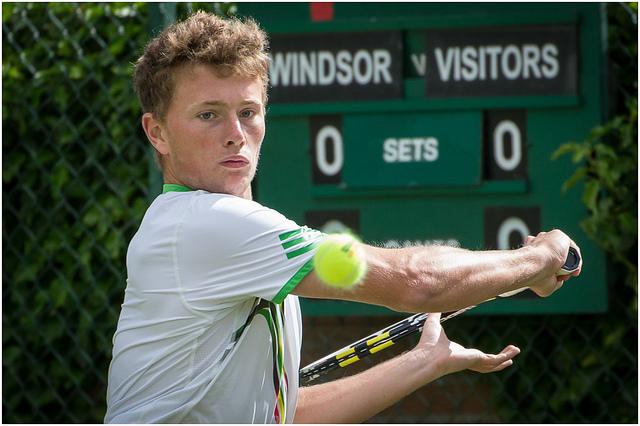What sport is being played?
Short answer required. Tennis. Is the player African?
Write a very short answer. No. Are the visitors in the lead?
Keep it brief. No. 